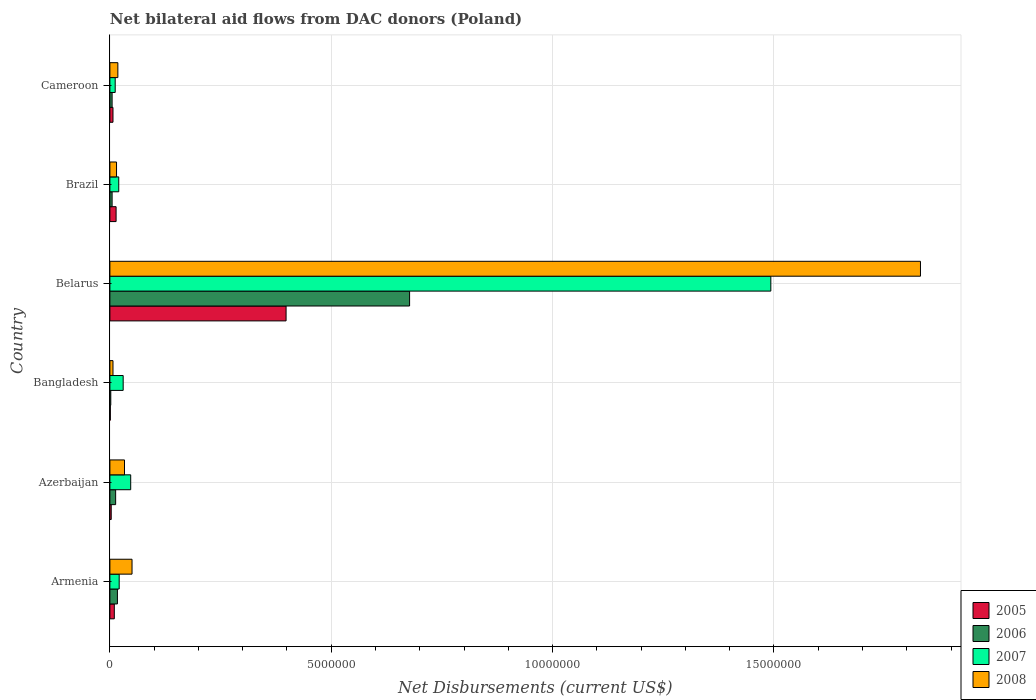How many different coloured bars are there?
Provide a short and direct response. 4. How many groups of bars are there?
Give a very brief answer. 6. Are the number of bars on each tick of the Y-axis equal?
Your answer should be compact. Yes. How many bars are there on the 6th tick from the top?
Offer a very short reply. 4. What is the label of the 5th group of bars from the top?
Give a very brief answer. Azerbaijan. What is the net bilateral aid flows in 2007 in Armenia?
Give a very brief answer. 2.10e+05. Across all countries, what is the maximum net bilateral aid flows in 2008?
Provide a short and direct response. 1.83e+07. In which country was the net bilateral aid flows in 2008 maximum?
Provide a succinct answer. Belarus. What is the total net bilateral aid flows in 2005 in the graph?
Your response must be concise. 4.33e+06. What is the difference between the net bilateral aid flows in 2006 in Armenia and that in Belarus?
Provide a succinct answer. -6.60e+06. What is the difference between the net bilateral aid flows in 2005 in Belarus and the net bilateral aid flows in 2008 in Armenia?
Ensure brevity in your answer.  3.48e+06. What is the average net bilateral aid flows in 2008 per country?
Offer a very short reply. 3.26e+06. What is the difference between the net bilateral aid flows in 2007 and net bilateral aid flows in 2008 in Belarus?
Your response must be concise. -3.38e+06. In how many countries, is the net bilateral aid flows in 2008 greater than 11000000 US$?
Provide a succinct answer. 1. What is the ratio of the net bilateral aid flows in 2005 in Azerbaijan to that in Bangladesh?
Ensure brevity in your answer.  3. Is the net bilateral aid flows in 2005 in Armenia less than that in Brazil?
Make the answer very short. Yes. Is the difference between the net bilateral aid flows in 2007 in Belarus and Brazil greater than the difference between the net bilateral aid flows in 2008 in Belarus and Brazil?
Your answer should be compact. No. What is the difference between the highest and the second highest net bilateral aid flows in 2006?
Your answer should be very brief. 6.60e+06. What is the difference between the highest and the lowest net bilateral aid flows in 2006?
Your response must be concise. 6.75e+06. In how many countries, is the net bilateral aid flows in 2008 greater than the average net bilateral aid flows in 2008 taken over all countries?
Provide a succinct answer. 1. Is the sum of the net bilateral aid flows in 2006 in Bangladesh and Brazil greater than the maximum net bilateral aid flows in 2007 across all countries?
Your answer should be very brief. No. Is it the case that in every country, the sum of the net bilateral aid flows in 2008 and net bilateral aid flows in 2006 is greater than the sum of net bilateral aid flows in 2005 and net bilateral aid flows in 2007?
Ensure brevity in your answer.  No. What does the 2nd bar from the top in Brazil represents?
Provide a succinct answer. 2007. What does the 4th bar from the bottom in Armenia represents?
Keep it short and to the point. 2008. Are all the bars in the graph horizontal?
Your response must be concise. Yes. Does the graph contain grids?
Offer a very short reply. Yes. Where does the legend appear in the graph?
Give a very brief answer. Bottom right. How many legend labels are there?
Offer a very short reply. 4. What is the title of the graph?
Offer a very short reply. Net bilateral aid flows from DAC donors (Poland). What is the label or title of the X-axis?
Provide a short and direct response. Net Disbursements (current US$). What is the label or title of the Y-axis?
Keep it short and to the point. Country. What is the Net Disbursements (current US$) of 2006 in Azerbaijan?
Give a very brief answer. 1.30e+05. What is the Net Disbursements (current US$) in 2005 in Bangladesh?
Provide a succinct answer. 10000. What is the Net Disbursements (current US$) in 2006 in Bangladesh?
Make the answer very short. 2.00e+04. What is the Net Disbursements (current US$) in 2007 in Bangladesh?
Ensure brevity in your answer.  3.00e+05. What is the Net Disbursements (current US$) in 2005 in Belarus?
Provide a succinct answer. 3.98e+06. What is the Net Disbursements (current US$) in 2006 in Belarus?
Provide a short and direct response. 6.77e+06. What is the Net Disbursements (current US$) in 2007 in Belarus?
Offer a very short reply. 1.49e+07. What is the Net Disbursements (current US$) in 2008 in Belarus?
Offer a very short reply. 1.83e+07. What is the Net Disbursements (current US$) of 2008 in Brazil?
Provide a short and direct response. 1.50e+05. What is the Net Disbursements (current US$) in 2007 in Cameroon?
Your answer should be very brief. 1.20e+05. What is the Net Disbursements (current US$) in 2008 in Cameroon?
Ensure brevity in your answer.  1.80e+05. Across all countries, what is the maximum Net Disbursements (current US$) in 2005?
Give a very brief answer. 3.98e+06. Across all countries, what is the maximum Net Disbursements (current US$) of 2006?
Make the answer very short. 6.77e+06. Across all countries, what is the maximum Net Disbursements (current US$) in 2007?
Provide a succinct answer. 1.49e+07. Across all countries, what is the maximum Net Disbursements (current US$) of 2008?
Keep it short and to the point. 1.83e+07. Across all countries, what is the minimum Net Disbursements (current US$) of 2006?
Give a very brief answer. 2.00e+04. Across all countries, what is the minimum Net Disbursements (current US$) in 2007?
Provide a succinct answer. 1.20e+05. What is the total Net Disbursements (current US$) in 2005 in the graph?
Your answer should be very brief. 4.33e+06. What is the total Net Disbursements (current US$) of 2006 in the graph?
Offer a terse response. 7.19e+06. What is the total Net Disbursements (current US$) of 2007 in the graph?
Provide a succinct answer. 1.62e+07. What is the total Net Disbursements (current US$) in 2008 in the graph?
Your answer should be compact. 1.95e+07. What is the difference between the Net Disbursements (current US$) in 2005 in Armenia and that in Azerbaijan?
Offer a terse response. 7.00e+04. What is the difference between the Net Disbursements (current US$) of 2007 in Armenia and that in Azerbaijan?
Make the answer very short. -2.60e+05. What is the difference between the Net Disbursements (current US$) in 2008 in Armenia and that in Azerbaijan?
Your answer should be compact. 1.70e+05. What is the difference between the Net Disbursements (current US$) of 2006 in Armenia and that in Bangladesh?
Keep it short and to the point. 1.50e+05. What is the difference between the Net Disbursements (current US$) of 2007 in Armenia and that in Bangladesh?
Your answer should be compact. -9.00e+04. What is the difference between the Net Disbursements (current US$) of 2005 in Armenia and that in Belarus?
Provide a short and direct response. -3.88e+06. What is the difference between the Net Disbursements (current US$) in 2006 in Armenia and that in Belarus?
Offer a very short reply. -6.60e+06. What is the difference between the Net Disbursements (current US$) in 2007 in Armenia and that in Belarus?
Your answer should be very brief. -1.47e+07. What is the difference between the Net Disbursements (current US$) of 2008 in Armenia and that in Belarus?
Keep it short and to the point. -1.78e+07. What is the difference between the Net Disbursements (current US$) in 2005 in Armenia and that in Brazil?
Make the answer very short. -4.00e+04. What is the difference between the Net Disbursements (current US$) of 2006 in Armenia and that in Brazil?
Your answer should be compact. 1.20e+05. What is the difference between the Net Disbursements (current US$) of 2008 in Armenia and that in Brazil?
Make the answer very short. 3.50e+05. What is the difference between the Net Disbursements (current US$) in 2005 in Armenia and that in Cameroon?
Ensure brevity in your answer.  3.00e+04. What is the difference between the Net Disbursements (current US$) in 2007 in Armenia and that in Cameroon?
Your answer should be very brief. 9.00e+04. What is the difference between the Net Disbursements (current US$) in 2005 in Azerbaijan and that in Bangladesh?
Provide a succinct answer. 2.00e+04. What is the difference between the Net Disbursements (current US$) in 2007 in Azerbaijan and that in Bangladesh?
Provide a succinct answer. 1.70e+05. What is the difference between the Net Disbursements (current US$) in 2008 in Azerbaijan and that in Bangladesh?
Ensure brevity in your answer.  2.60e+05. What is the difference between the Net Disbursements (current US$) of 2005 in Azerbaijan and that in Belarus?
Your answer should be compact. -3.95e+06. What is the difference between the Net Disbursements (current US$) of 2006 in Azerbaijan and that in Belarus?
Make the answer very short. -6.64e+06. What is the difference between the Net Disbursements (current US$) of 2007 in Azerbaijan and that in Belarus?
Offer a terse response. -1.45e+07. What is the difference between the Net Disbursements (current US$) of 2008 in Azerbaijan and that in Belarus?
Give a very brief answer. -1.80e+07. What is the difference between the Net Disbursements (current US$) of 2005 in Azerbaijan and that in Brazil?
Offer a very short reply. -1.10e+05. What is the difference between the Net Disbursements (current US$) of 2006 in Azerbaijan and that in Brazil?
Ensure brevity in your answer.  8.00e+04. What is the difference between the Net Disbursements (current US$) of 2008 in Azerbaijan and that in Brazil?
Provide a short and direct response. 1.80e+05. What is the difference between the Net Disbursements (current US$) of 2005 in Azerbaijan and that in Cameroon?
Provide a short and direct response. -4.00e+04. What is the difference between the Net Disbursements (current US$) of 2006 in Azerbaijan and that in Cameroon?
Provide a short and direct response. 8.00e+04. What is the difference between the Net Disbursements (current US$) in 2008 in Azerbaijan and that in Cameroon?
Offer a terse response. 1.50e+05. What is the difference between the Net Disbursements (current US$) of 2005 in Bangladesh and that in Belarus?
Give a very brief answer. -3.97e+06. What is the difference between the Net Disbursements (current US$) of 2006 in Bangladesh and that in Belarus?
Keep it short and to the point. -6.75e+06. What is the difference between the Net Disbursements (current US$) of 2007 in Bangladesh and that in Belarus?
Provide a succinct answer. -1.46e+07. What is the difference between the Net Disbursements (current US$) of 2008 in Bangladesh and that in Belarus?
Offer a very short reply. -1.82e+07. What is the difference between the Net Disbursements (current US$) in 2007 in Bangladesh and that in Brazil?
Your response must be concise. 1.00e+05. What is the difference between the Net Disbursements (current US$) of 2006 in Bangladesh and that in Cameroon?
Provide a succinct answer. -3.00e+04. What is the difference between the Net Disbursements (current US$) in 2007 in Bangladesh and that in Cameroon?
Give a very brief answer. 1.80e+05. What is the difference between the Net Disbursements (current US$) in 2005 in Belarus and that in Brazil?
Make the answer very short. 3.84e+06. What is the difference between the Net Disbursements (current US$) in 2006 in Belarus and that in Brazil?
Keep it short and to the point. 6.72e+06. What is the difference between the Net Disbursements (current US$) in 2007 in Belarus and that in Brazil?
Your response must be concise. 1.47e+07. What is the difference between the Net Disbursements (current US$) in 2008 in Belarus and that in Brazil?
Your answer should be compact. 1.82e+07. What is the difference between the Net Disbursements (current US$) in 2005 in Belarus and that in Cameroon?
Keep it short and to the point. 3.91e+06. What is the difference between the Net Disbursements (current US$) in 2006 in Belarus and that in Cameroon?
Offer a terse response. 6.72e+06. What is the difference between the Net Disbursements (current US$) of 2007 in Belarus and that in Cameroon?
Offer a very short reply. 1.48e+07. What is the difference between the Net Disbursements (current US$) of 2008 in Belarus and that in Cameroon?
Provide a short and direct response. 1.81e+07. What is the difference between the Net Disbursements (current US$) in 2005 in Brazil and that in Cameroon?
Your response must be concise. 7.00e+04. What is the difference between the Net Disbursements (current US$) in 2006 in Brazil and that in Cameroon?
Your response must be concise. 0. What is the difference between the Net Disbursements (current US$) in 2007 in Brazil and that in Cameroon?
Ensure brevity in your answer.  8.00e+04. What is the difference between the Net Disbursements (current US$) of 2008 in Brazil and that in Cameroon?
Your response must be concise. -3.00e+04. What is the difference between the Net Disbursements (current US$) in 2005 in Armenia and the Net Disbursements (current US$) in 2006 in Azerbaijan?
Give a very brief answer. -3.00e+04. What is the difference between the Net Disbursements (current US$) of 2005 in Armenia and the Net Disbursements (current US$) of 2007 in Azerbaijan?
Your answer should be compact. -3.70e+05. What is the difference between the Net Disbursements (current US$) of 2006 in Armenia and the Net Disbursements (current US$) of 2007 in Azerbaijan?
Your answer should be very brief. -3.00e+05. What is the difference between the Net Disbursements (current US$) in 2006 in Armenia and the Net Disbursements (current US$) in 2008 in Azerbaijan?
Offer a very short reply. -1.60e+05. What is the difference between the Net Disbursements (current US$) of 2007 in Armenia and the Net Disbursements (current US$) of 2008 in Azerbaijan?
Offer a terse response. -1.20e+05. What is the difference between the Net Disbursements (current US$) of 2005 in Armenia and the Net Disbursements (current US$) of 2006 in Bangladesh?
Your response must be concise. 8.00e+04. What is the difference between the Net Disbursements (current US$) of 2005 in Armenia and the Net Disbursements (current US$) of 2007 in Bangladesh?
Provide a succinct answer. -2.00e+05. What is the difference between the Net Disbursements (current US$) of 2005 in Armenia and the Net Disbursements (current US$) of 2008 in Bangladesh?
Keep it short and to the point. 3.00e+04. What is the difference between the Net Disbursements (current US$) of 2006 in Armenia and the Net Disbursements (current US$) of 2007 in Bangladesh?
Offer a very short reply. -1.30e+05. What is the difference between the Net Disbursements (current US$) of 2006 in Armenia and the Net Disbursements (current US$) of 2008 in Bangladesh?
Give a very brief answer. 1.00e+05. What is the difference between the Net Disbursements (current US$) of 2007 in Armenia and the Net Disbursements (current US$) of 2008 in Bangladesh?
Offer a very short reply. 1.40e+05. What is the difference between the Net Disbursements (current US$) of 2005 in Armenia and the Net Disbursements (current US$) of 2006 in Belarus?
Your answer should be very brief. -6.67e+06. What is the difference between the Net Disbursements (current US$) of 2005 in Armenia and the Net Disbursements (current US$) of 2007 in Belarus?
Ensure brevity in your answer.  -1.48e+07. What is the difference between the Net Disbursements (current US$) of 2005 in Armenia and the Net Disbursements (current US$) of 2008 in Belarus?
Give a very brief answer. -1.82e+07. What is the difference between the Net Disbursements (current US$) of 2006 in Armenia and the Net Disbursements (current US$) of 2007 in Belarus?
Keep it short and to the point. -1.48e+07. What is the difference between the Net Disbursements (current US$) in 2006 in Armenia and the Net Disbursements (current US$) in 2008 in Belarus?
Offer a very short reply. -1.81e+07. What is the difference between the Net Disbursements (current US$) in 2007 in Armenia and the Net Disbursements (current US$) in 2008 in Belarus?
Offer a very short reply. -1.81e+07. What is the difference between the Net Disbursements (current US$) of 2005 in Armenia and the Net Disbursements (current US$) of 2006 in Brazil?
Provide a succinct answer. 5.00e+04. What is the difference between the Net Disbursements (current US$) of 2005 in Armenia and the Net Disbursements (current US$) of 2008 in Brazil?
Offer a very short reply. -5.00e+04. What is the difference between the Net Disbursements (current US$) of 2005 in Armenia and the Net Disbursements (current US$) of 2007 in Cameroon?
Provide a succinct answer. -2.00e+04. What is the difference between the Net Disbursements (current US$) of 2005 in Armenia and the Net Disbursements (current US$) of 2008 in Cameroon?
Give a very brief answer. -8.00e+04. What is the difference between the Net Disbursements (current US$) of 2006 in Armenia and the Net Disbursements (current US$) of 2007 in Cameroon?
Provide a succinct answer. 5.00e+04. What is the difference between the Net Disbursements (current US$) in 2006 in Armenia and the Net Disbursements (current US$) in 2008 in Cameroon?
Your answer should be very brief. -10000. What is the difference between the Net Disbursements (current US$) of 2005 in Azerbaijan and the Net Disbursements (current US$) of 2006 in Bangladesh?
Offer a terse response. 10000. What is the difference between the Net Disbursements (current US$) in 2005 in Azerbaijan and the Net Disbursements (current US$) in 2007 in Bangladesh?
Provide a succinct answer. -2.70e+05. What is the difference between the Net Disbursements (current US$) of 2006 in Azerbaijan and the Net Disbursements (current US$) of 2007 in Bangladesh?
Offer a terse response. -1.70e+05. What is the difference between the Net Disbursements (current US$) of 2005 in Azerbaijan and the Net Disbursements (current US$) of 2006 in Belarus?
Ensure brevity in your answer.  -6.74e+06. What is the difference between the Net Disbursements (current US$) of 2005 in Azerbaijan and the Net Disbursements (current US$) of 2007 in Belarus?
Your answer should be compact. -1.49e+07. What is the difference between the Net Disbursements (current US$) of 2005 in Azerbaijan and the Net Disbursements (current US$) of 2008 in Belarus?
Offer a terse response. -1.83e+07. What is the difference between the Net Disbursements (current US$) in 2006 in Azerbaijan and the Net Disbursements (current US$) in 2007 in Belarus?
Offer a terse response. -1.48e+07. What is the difference between the Net Disbursements (current US$) of 2006 in Azerbaijan and the Net Disbursements (current US$) of 2008 in Belarus?
Your answer should be very brief. -1.82e+07. What is the difference between the Net Disbursements (current US$) in 2007 in Azerbaijan and the Net Disbursements (current US$) in 2008 in Belarus?
Your answer should be compact. -1.78e+07. What is the difference between the Net Disbursements (current US$) in 2005 in Azerbaijan and the Net Disbursements (current US$) in 2006 in Brazil?
Your answer should be compact. -2.00e+04. What is the difference between the Net Disbursements (current US$) in 2006 in Azerbaijan and the Net Disbursements (current US$) in 2008 in Brazil?
Give a very brief answer. -2.00e+04. What is the difference between the Net Disbursements (current US$) of 2005 in Azerbaijan and the Net Disbursements (current US$) of 2006 in Cameroon?
Your response must be concise. -2.00e+04. What is the difference between the Net Disbursements (current US$) in 2005 in Azerbaijan and the Net Disbursements (current US$) in 2007 in Cameroon?
Ensure brevity in your answer.  -9.00e+04. What is the difference between the Net Disbursements (current US$) in 2006 in Azerbaijan and the Net Disbursements (current US$) in 2008 in Cameroon?
Your answer should be compact. -5.00e+04. What is the difference between the Net Disbursements (current US$) of 2005 in Bangladesh and the Net Disbursements (current US$) of 2006 in Belarus?
Your response must be concise. -6.76e+06. What is the difference between the Net Disbursements (current US$) in 2005 in Bangladesh and the Net Disbursements (current US$) in 2007 in Belarus?
Your answer should be very brief. -1.49e+07. What is the difference between the Net Disbursements (current US$) in 2005 in Bangladesh and the Net Disbursements (current US$) in 2008 in Belarus?
Provide a short and direct response. -1.83e+07. What is the difference between the Net Disbursements (current US$) of 2006 in Bangladesh and the Net Disbursements (current US$) of 2007 in Belarus?
Your answer should be very brief. -1.49e+07. What is the difference between the Net Disbursements (current US$) of 2006 in Bangladesh and the Net Disbursements (current US$) of 2008 in Belarus?
Ensure brevity in your answer.  -1.83e+07. What is the difference between the Net Disbursements (current US$) of 2007 in Bangladesh and the Net Disbursements (current US$) of 2008 in Belarus?
Make the answer very short. -1.80e+07. What is the difference between the Net Disbursements (current US$) of 2005 in Bangladesh and the Net Disbursements (current US$) of 2006 in Brazil?
Provide a succinct answer. -4.00e+04. What is the difference between the Net Disbursements (current US$) in 2005 in Bangladesh and the Net Disbursements (current US$) in 2007 in Brazil?
Your answer should be compact. -1.90e+05. What is the difference between the Net Disbursements (current US$) of 2005 in Bangladesh and the Net Disbursements (current US$) of 2008 in Brazil?
Give a very brief answer. -1.40e+05. What is the difference between the Net Disbursements (current US$) in 2006 in Bangladesh and the Net Disbursements (current US$) in 2008 in Brazil?
Provide a short and direct response. -1.30e+05. What is the difference between the Net Disbursements (current US$) in 2005 in Bangladesh and the Net Disbursements (current US$) in 2007 in Cameroon?
Give a very brief answer. -1.10e+05. What is the difference between the Net Disbursements (current US$) in 2005 in Belarus and the Net Disbursements (current US$) in 2006 in Brazil?
Your answer should be compact. 3.93e+06. What is the difference between the Net Disbursements (current US$) of 2005 in Belarus and the Net Disbursements (current US$) of 2007 in Brazil?
Make the answer very short. 3.78e+06. What is the difference between the Net Disbursements (current US$) of 2005 in Belarus and the Net Disbursements (current US$) of 2008 in Brazil?
Give a very brief answer. 3.83e+06. What is the difference between the Net Disbursements (current US$) in 2006 in Belarus and the Net Disbursements (current US$) in 2007 in Brazil?
Keep it short and to the point. 6.57e+06. What is the difference between the Net Disbursements (current US$) in 2006 in Belarus and the Net Disbursements (current US$) in 2008 in Brazil?
Give a very brief answer. 6.62e+06. What is the difference between the Net Disbursements (current US$) in 2007 in Belarus and the Net Disbursements (current US$) in 2008 in Brazil?
Make the answer very short. 1.48e+07. What is the difference between the Net Disbursements (current US$) in 2005 in Belarus and the Net Disbursements (current US$) in 2006 in Cameroon?
Ensure brevity in your answer.  3.93e+06. What is the difference between the Net Disbursements (current US$) in 2005 in Belarus and the Net Disbursements (current US$) in 2007 in Cameroon?
Provide a short and direct response. 3.86e+06. What is the difference between the Net Disbursements (current US$) of 2005 in Belarus and the Net Disbursements (current US$) of 2008 in Cameroon?
Provide a short and direct response. 3.80e+06. What is the difference between the Net Disbursements (current US$) of 2006 in Belarus and the Net Disbursements (current US$) of 2007 in Cameroon?
Give a very brief answer. 6.65e+06. What is the difference between the Net Disbursements (current US$) of 2006 in Belarus and the Net Disbursements (current US$) of 2008 in Cameroon?
Keep it short and to the point. 6.59e+06. What is the difference between the Net Disbursements (current US$) of 2007 in Belarus and the Net Disbursements (current US$) of 2008 in Cameroon?
Offer a very short reply. 1.48e+07. What is the difference between the Net Disbursements (current US$) in 2005 in Brazil and the Net Disbursements (current US$) in 2008 in Cameroon?
Offer a very short reply. -4.00e+04. What is the difference between the Net Disbursements (current US$) of 2006 in Brazil and the Net Disbursements (current US$) of 2007 in Cameroon?
Your answer should be compact. -7.00e+04. What is the average Net Disbursements (current US$) in 2005 per country?
Provide a succinct answer. 7.22e+05. What is the average Net Disbursements (current US$) of 2006 per country?
Ensure brevity in your answer.  1.20e+06. What is the average Net Disbursements (current US$) of 2007 per country?
Provide a short and direct response. 2.70e+06. What is the average Net Disbursements (current US$) of 2008 per country?
Your response must be concise. 3.26e+06. What is the difference between the Net Disbursements (current US$) of 2005 and Net Disbursements (current US$) of 2008 in Armenia?
Your answer should be very brief. -4.00e+05. What is the difference between the Net Disbursements (current US$) of 2006 and Net Disbursements (current US$) of 2007 in Armenia?
Your response must be concise. -4.00e+04. What is the difference between the Net Disbursements (current US$) in 2006 and Net Disbursements (current US$) in 2008 in Armenia?
Provide a short and direct response. -3.30e+05. What is the difference between the Net Disbursements (current US$) in 2007 and Net Disbursements (current US$) in 2008 in Armenia?
Your answer should be compact. -2.90e+05. What is the difference between the Net Disbursements (current US$) in 2005 and Net Disbursements (current US$) in 2006 in Azerbaijan?
Provide a succinct answer. -1.00e+05. What is the difference between the Net Disbursements (current US$) of 2005 and Net Disbursements (current US$) of 2007 in Azerbaijan?
Offer a terse response. -4.40e+05. What is the difference between the Net Disbursements (current US$) in 2006 and Net Disbursements (current US$) in 2008 in Azerbaijan?
Ensure brevity in your answer.  -2.00e+05. What is the difference between the Net Disbursements (current US$) of 2007 and Net Disbursements (current US$) of 2008 in Azerbaijan?
Your answer should be very brief. 1.40e+05. What is the difference between the Net Disbursements (current US$) in 2005 and Net Disbursements (current US$) in 2008 in Bangladesh?
Give a very brief answer. -6.00e+04. What is the difference between the Net Disbursements (current US$) of 2006 and Net Disbursements (current US$) of 2007 in Bangladesh?
Your response must be concise. -2.80e+05. What is the difference between the Net Disbursements (current US$) in 2005 and Net Disbursements (current US$) in 2006 in Belarus?
Offer a very short reply. -2.79e+06. What is the difference between the Net Disbursements (current US$) of 2005 and Net Disbursements (current US$) of 2007 in Belarus?
Keep it short and to the point. -1.10e+07. What is the difference between the Net Disbursements (current US$) of 2005 and Net Disbursements (current US$) of 2008 in Belarus?
Keep it short and to the point. -1.43e+07. What is the difference between the Net Disbursements (current US$) of 2006 and Net Disbursements (current US$) of 2007 in Belarus?
Your response must be concise. -8.16e+06. What is the difference between the Net Disbursements (current US$) of 2006 and Net Disbursements (current US$) of 2008 in Belarus?
Your answer should be very brief. -1.15e+07. What is the difference between the Net Disbursements (current US$) in 2007 and Net Disbursements (current US$) in 2008 in Belarus?
Your response must be concise. -3.38e+06. What is the difference between the Net Disbursements (current US$) of 2005 and Net Disbursements (current US$) of 2007 in Brazil?
Offer a very short reply. -6.00e+04. What is the difference between the Net Disbursements (current US$) in 2006 and Net Disbursements (current US$) in 2007 in Brazil?
Keep it short and to the point. -1.50e+05. What is the difference between the Net Disbursements (current US$) of 2005 and Net Disbursements (current US$) of 2006 in Cameroon?
Your response must be concise. 2.00e+04. What is the difference between the Net Disbursements (current US$) in 2005 and Net Disbursements (current US$) in 2008 in Cameroon?
Your answer should be compact. -1.10e+05. What is the ratio of the Net Disbursements (current US$) in 2005 in Armenia to that in Azerbaijan?
Keep it short and to the point. 3.33. What is the ratio of the Net Disbursements (current US$) of 2006 in Armenia to that in Azerbaijan?
Give a very brief answer. 1.31. What is the ratio of the Net Disbursements (current US$) in 2007 in Armenia to that in Azerbaijan?
Your answer should be very brief. 0.45. What is the ratio of the Net Disbursements (current US$) of 2008 in Armenia to that in Azerbaijan?
Your answer should be very brief. 1.52. What is the ratio of the Net Disbursements (current US$) in 2005 in Armenia to that in Bangladesh?
Provide a succinct answer. 10. What is the ratio of the Net Disbursements (current US$) in 2006 in Armenia to that in Bangladesh?
Your response must be concise. 8.5. What is the ratio of the Net Disbursements (current US$) of 2008 in Armenia to that in Bangladesh?
Make the answer very short. 7.14. What is the ratio of the Net Disbursements (current US$) in 2005 in Armenia to that in Belarus?
Your answer should be compact. 0.03. What is the ratio of the Net Disbursements (current US$) in 2006 in Armenia to that in Belarus?
Offer a terse response. 0.03. What is the ratio of the Net Disbursements (current US$) of 2007 in Armenia to that in Belarus?
Make the answer very short. 0.01. What is the ratio of the Net Disbursements (current US$) in 2008 in Armenia to that in Belarus?
Ensure brevity in your answer.  0.03. What is the ratio of the Net Disbursements (current US$) in 2005 in Armenia to that in Brazil?
Your answer should be very brief. 0.71. What is the ratio of the Net Disbursements (current US$) in 2005 in Armenia to that in Cameroon?
Provide a short and direct response. 1.43. What is the ratio of the Net Disbursements (current US$) in 2008 in Armenia to that in Cameroon?
Offer a very short reply. 2.78. What is the ratio of the Net Disbursements (current US$) of 2007 in Azerbaijan to that in Bangladesh?
Your response must be concise. 1.57. What is the ratio of the Net Disbursements (current US$) in 2008 in Azerbaijan to that in Bangladesh?
Your response must be concise. 4.71. What is the ratio of the Net Disbursements (current US$) of 2005 in Azerbaijan to that in Belarus?
Provide a succinct answer. 0.01. What is the ratio of the Net Disbursements (current US$) of 2006 in Azerbaijan to that in Belarus?
Keep it short and to the point. 0.02. What is the ratio of the Net Disbursements (current US$) of 2007 in Azerbaijan to that in Belarus?
Offer a very short reply. 0.03. What is the ratio of the Net Disbursements (current US$) of 2008 in Azerbaijan to that in Belarus?
Your answer should be compact. 0.02. What is the ratio of the Net Disbursements (current US$) in 2005 in Azerbaijan to that in Brazil?
Offer a terse response. 0.21. What is the ratio of the Net Disbursements (current US$) in 2007 in Azerbaijan to that in Brazil?
Keep it short and to the point. 2.35. What is the ratio of the Net Disbursements (current US$) in 2005 in Azerbaijan to that in Cameroon?
Make the answer very short. 0.43. What is the ratio of the Net Disbursements (current US$) in 2007 in Azerbaijan to that in Cameroon?
Provide a succinct answer. 3.92. What is the ratio of the Net Disbursements (current US$) of 2008 in Azerbaijan to that in Cameroon?
Provide a succinct answer. 1.83. What is the ratio of the Net Disbursements (current US$) in 2005 in Bangladesh to that in Belarus?
Make the answer very short. 0. What is the ratio of the Net Disbursements (current US$) in 2006 in Bangladesh to that in Belarus?
Make the answer very short. 0. What is the ratio of the Net Disbursements (current US$) in 2007 in Bangladesh to that in Belarus?
Your answer should be compact. 0.02. What is the ratio of the Net Disbursements (current US$) of 2008 in Bangladesh to that in Belarus?
Your answer should be compact. 0. What is the ratio of the Net Disbursements (current US$) of 2005 in Bangladesh to that in Brazil?
Offer a very short reply. 0.07. What is the ratio of the Net Disbursements (current US$) in 2008 in Bangladesh to that in Brazil?
Make the answer very short. 0.47. What is the ratio of the Net Disbursements (current US$) in 2005 in Bangladesh to that in Cameroon?
Your answer should be compact. 0.14. What is the ratio of the Net Disbursements (current US$) of 2008 in Bangladesh to that in Cameroon?
Provide a short and direct response. 0.39. What is the ratio of the Net Disbursements (current US$) of 2005 in Belarus to that in Brazil?
Your answer should be compact. 28.43. What is the ratio of the Net Disbursements (current US$) in 2006 in Belarus to that in Brazil?
Your answer should be compact. 135.4. What is the ratio of the Net Disbursements (current US$) in 2007 in Belarus to that in Brazil?
Offer a terse response. 74.65. What is the ratio of the Net Disbursements (current US$) in 2008 in Belarus to that in Brazil?
Your answer should be very brief. 122.07. What is the ratio of the Net Disbursements (current US$) in 2005 in Belarus to that in Cameroon?
Your answer should be very brief. 56.86. What is the ratio of the Net Disbursements (current US$) of 2006 in Belarus to that in Cameroon?
Offer a terse response. 135.4. What is the ratio of the Net Disbursements (current US$) in 2007 in Belarus to that in Cameroon?
Give a very brief answer. 124.42. What is the ratio of the Net Disbursements (current US$) in 2008 in Belarus to that in Cameroon?
Ensure brevity in your answer.  101.72. What is the ratio of the Net Disbursements (current US$) of 2005 in Brazil to that in Cameroon?
Provide a succinct answer. 2. What is the ratio of the Net Disbursements (current US$) in 2008 in Brazil to that in Cameroon?
Offer a terse response. 0.83. What is the difference between the highest and the second highest Net Disbursements (current US$) in 2005?
Your response must be concise. 3.84e+06. What is the difference between the highest and the second highest Net Disbursements (current US$) of 2006?
Ensure brevity in your answer.  6.60e+06. What is the difference between the highest and the second highest Net Disbursements (current US$) in 2007?
Your answer should be very brief. 1.45e+07. What is the difference between the highest and the second highest Net Disbursements (current US$) in 2008?
Keep it short and to the point. 1.78e+07. What is the difference between the highest and the lowest Net Disbursements (current US$) in 2005?
Provide a succinct answer. 3.97e+06. What is the difference between the highest and the lowest Net Disbursements (current US$) in 2006?
Your answer should be very brief. 6.75e+06. What is the difference between the highest and the lowest Net Disbursements (current US$) of 2007?
Your response must be concise. 1.48e+07. What is the difference between the highest and the lowest Net Disbursements (current US$) in 2008?
Ensure brevity in your answer.  1.82e+07. 